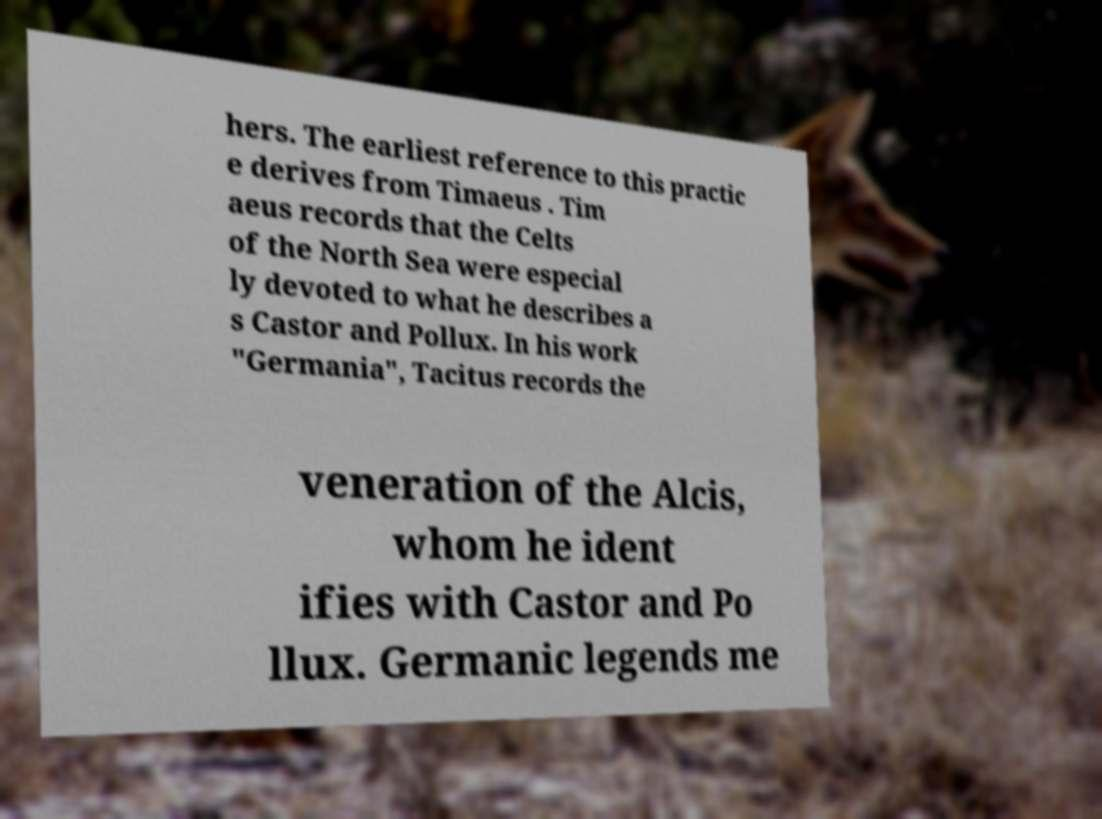What messages or text are displayed in this image? I need them in a readable, typed format. hers. The earliest reference to this practic e derives from Timaeus . Tim aeus records that the Celts of the North Sea were especial ly devoted to what he describes a s Castor and Pollux. In his work "Germania", Tacitus records the veneration of the Alcis, whom he ident ifies with Castor and Po llux. Germanic legends me 